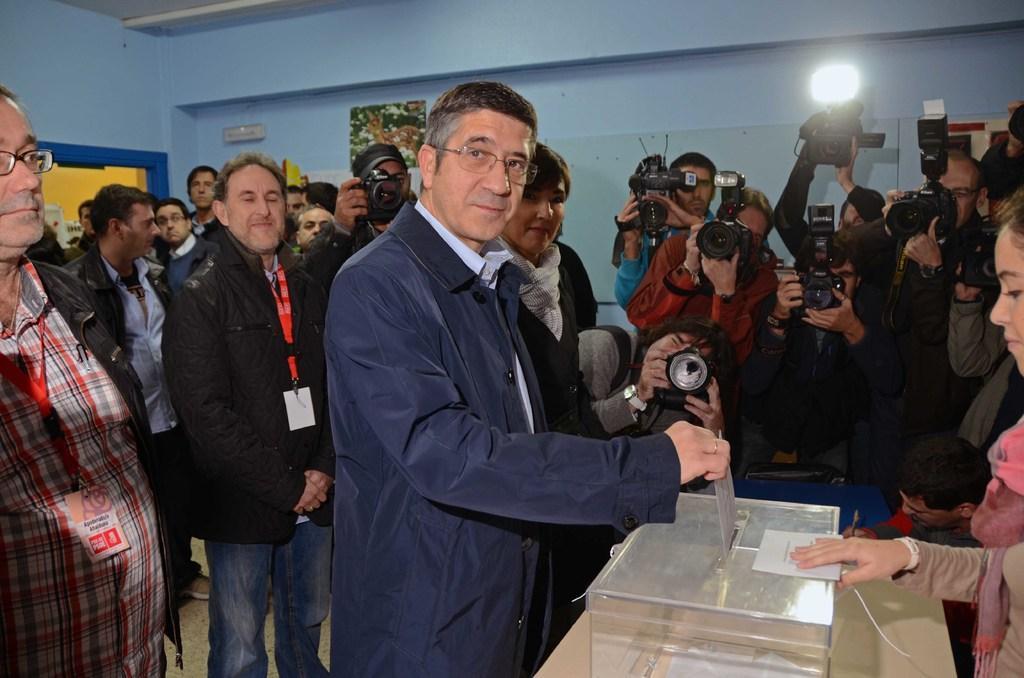Describe this image in one or two sentences. In the picture we can see a hall with some people standing, holding cameras and capturing the pictures of a man who is casting his vote in the box which is on the table and behind the table, we can see a woman is standing, and behind the man we can see some people are standing in tags and ID cards, and in the background we can see some posters to the wall. 